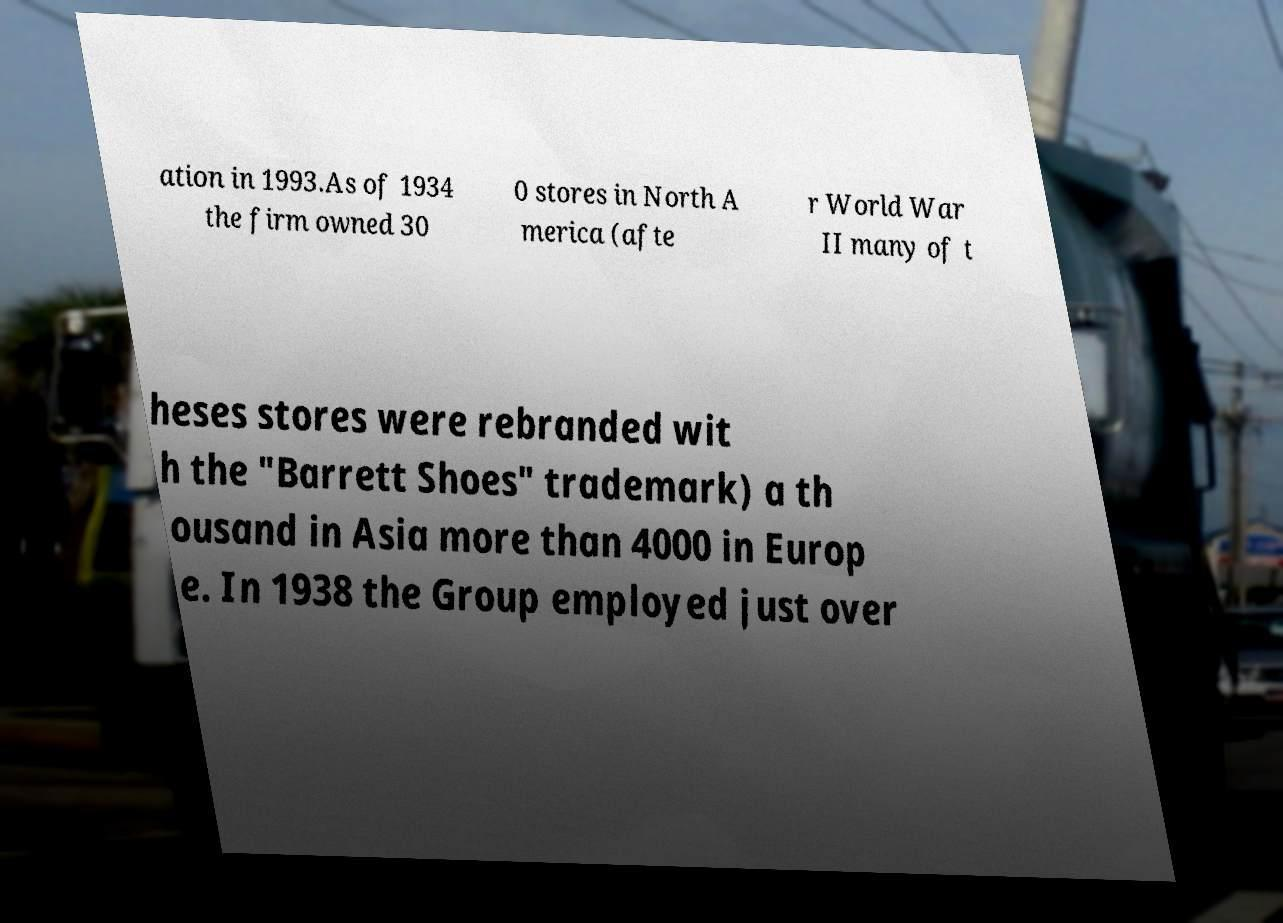Please identify and transcribe the text found in this image. ation in 1993.As of 1934 the firm owned 30 0 stores in North A merica (afte r World War II many of t heses stores were rebranded wit h the "Barrett Shoes" trademark) a th ousand in Asia more than 4000 in Europ e. In 1938 the Group employed just over 